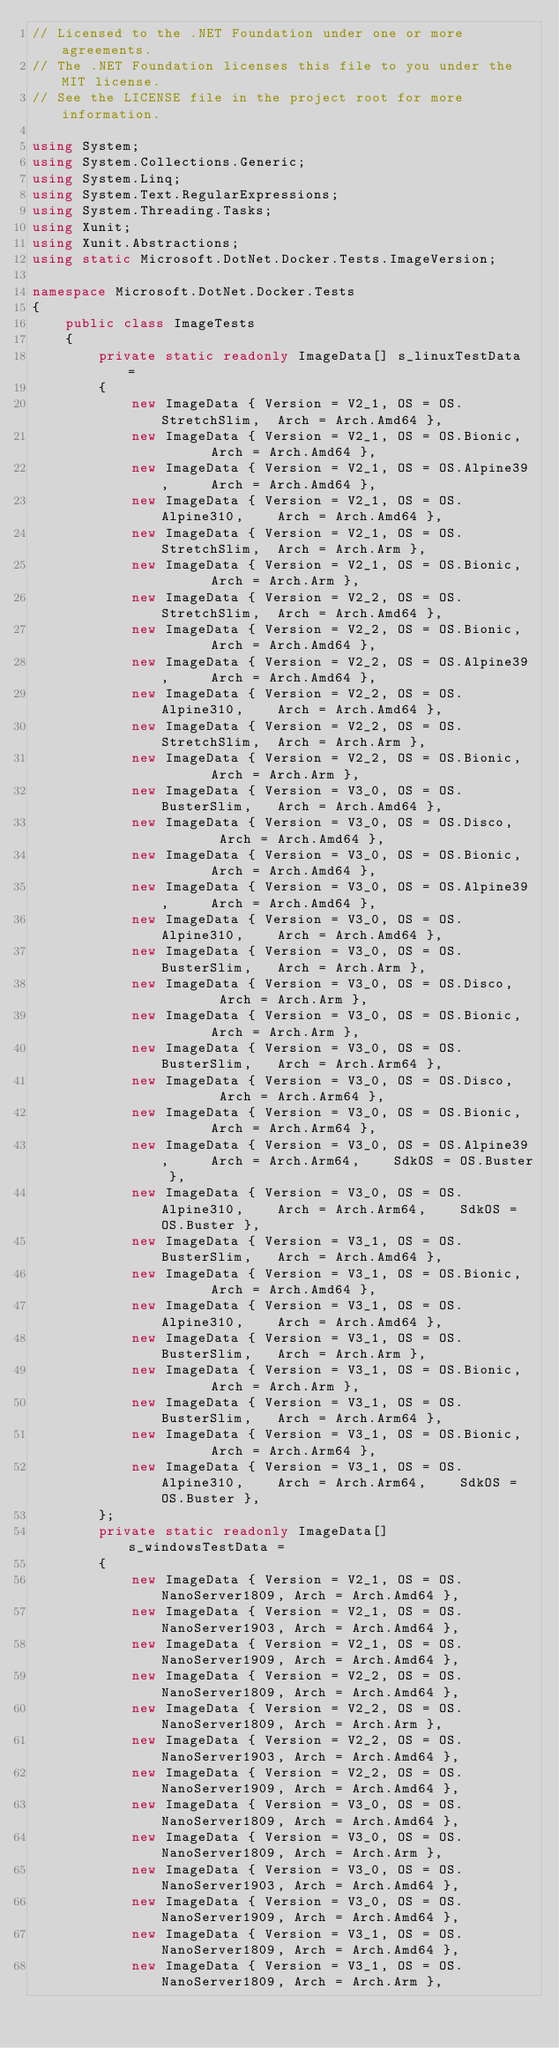Convert code to text. <code><loc_0><loc_0><loc_500><loc_500><_C#_>// Licensed to the .NET Foundation under one or more agreements.
// The .NET Foundation licenses this file to you under the MIT license.
// See the LICENSE file in the project root for more information.

using System;
using System.Collections.Generic;
using System.Linq;
using System.Text.RegularExpressions;
using System.Threading.Tasks;
using Xunit;
using Xunit.Abstractions;
using static Microsoft.DotNet.Docker.Tests.ImageVersion;

namespace Microsoft.DotNet.Docker.Tests
{
    public class ImageTests
    {
        private static readonly ImageData[] s_linuxTestData =
        {
            new ImageData { Version = V2_1, OS = OS.StretchSlim,  Arch = Arch.Amd64 },
            new ImageData { Version = V2_1, OS = OS.Bionic,       Arch = Arch.Amd64 },
            new ImageData { Version = V2_1, OS = OS.Alpine39,     Arch = Arch.Amd64 },
            new ImageData { Version = V2_1, OS = OS.Alpine310,    Arch = Arch.Amd64 },
            new ImageData { Version = V2_1, OS = OS.StretchSlim,  Arch = Arch.Arm },
            new ImageData { Version = V2_1, OS = OS.Bionic,       Arch = Arch.Arm },
            new ImageData { Version = V2_2, OS = OS.StretchSlim,  Arch = Arch.Amd64 },
            new ImageData { Version = V2_2, OS = OS.Bionic,       Arch = Arch.Amd64 },
            new ImageData { Version = V2_2, OS = OS.Alpine39,     Arch = Arch.Amd64 },
            new ImageData { Version = V2_2, OS = OS.Alpine310,    Arch = Arch.Amd64 },
            new ImageData { Version = V2_2, OS = OS.StretchSlim,  Arch = Arch.Arm },
            new ImageData { Version = V2_2, OS = OS.Bionic,       Arch = Arch.Arm },
            new ImageData { Version = V3_0, OS = OS.BusterSlim,   Arch = Arch.Amd64 },
            new ImageData { Version = V3_0, OS = OS.Disco,        Arch = Arch.Amd64 },
            new ImageData { Version = V3_0, OS = OS.Bionic,       Arch = Arch.Amd64 },
            new ImageData { Version = V3_0, OS = OS.Alpine39,     Arch = Arch.Amd64 },
            new ImageData { Version = V3_0, OS = OS.Alpine310,    Arch = Arch.Amd64 },
            new ImageData { Version = V3_0, OS = OS.BusterSlim,   Arch = Arch.Arm },
            new ImageData { Version = V3_0, OS = OS.Disco,        Arch = Arch.Arm },
            new ImageData { Version = V3_0, OS = OS.Bionic,       Arch = Arch.Arm },
            new ImageData { Version = V3_0, OS = OS.BusterSlim,   Arch = Arch.Arm64 },
            new ImageData { Version = V3_0, OS = OS.Disco,        Arch = Arch.Arm64 },
            new ImageData { Version = V3_0, OS = OS.Bionic,       Arch = Arch.Arm64 },
            new ImageData { Version = V3_0, OS = OS.Alpine39,     Arch = Arch.Arm64,    SdkOS = OS.Buster },
            new ImageData { Version = V3_0, OS = OS.Alpine310,    Arch = Arch.Arm64,    SdkOS = OS.Buster },
            new ImageData { Version = V3_1, OS = OS.BusterSlim,   Arch = Arch.Amd64 },
            new ImageData { Version = V3_1, OS = OS.Bionic,       Arch = Arch.Amd64 },
            new ImageData { Version = V3_1, OS = OS.Alpine310,    Arch = Arch.Amd64 },
            new ImageData { Version = V3_1, OS = OS.BusterSlim,   Arch = Arch.Arm },
            new ImageData { Version = V3_1, OS = OS.Bionic,       Arch = Arch.Arm },
            new ImageData { Version = V3_1, OS = OS.BusterSlim,   Arch = Arch.Arm64 },
            new ImageData { Version = V3_1, OS = OS.Bionic,       Arch = Arch.Arm64 },
            new ImageData { Version = V3_1, OS = OS.Alpine310,    Arch = Arch.Arm64,    SdkOS = OS.Buster },
        };
        private static readonly ImageData[] s_windowsTestData =
        {
            new ImageData { Version = V2_1, OS = OS.NanoServer1809, Arch = Arch.Amd64 },
            new ImageData { Version = V2_1, OS = OS.NanoServer1903, Arch = Arch.Amd64 },
            new ImageData { Version = V2_1, OS = OS.NanoServer1909, Arch = Arch.Amd64 },
            new ImageData { Version = V2_2, OS = OS.NanoServer1809, Arch = Arch.Amd64 },
            new ImageData { Version = V2_2, OS = OS.NanoServer1809, Arch = Arch.Arm },
            new ImageData { Version = V2_2, OS = OS.NanoServer1903, Arch = Arch.Amd64 },
            new ImageData { Version = V2_2, OS = OS.NanoServer1909, Arch = Arch.Amd64 },
            new ImageData { Version = V3_0, OS = OS.NanoServer1809, Arch = Arch.Amd64 },
            new ImageData { Version = V3_0, OS = OS.NanoServer1809, Arch = Arch.Arm },
            new ImageData { Version = V3_0, OS = OS.NanoServer1903, Arch = Arch.Amd64 },
            new ImageData { Version = V3_0, OS = OS.NanoServer1909, Arch = Arch.Amd64 },
            new ImageData { Version = V3_1, OS = OS.NanoServer1809, Arch = Arch.Amd64 },
            new ImageData { Version = V3_1, OS = OS.NanoServer1809, Arch = Arch.Arm },</code> 